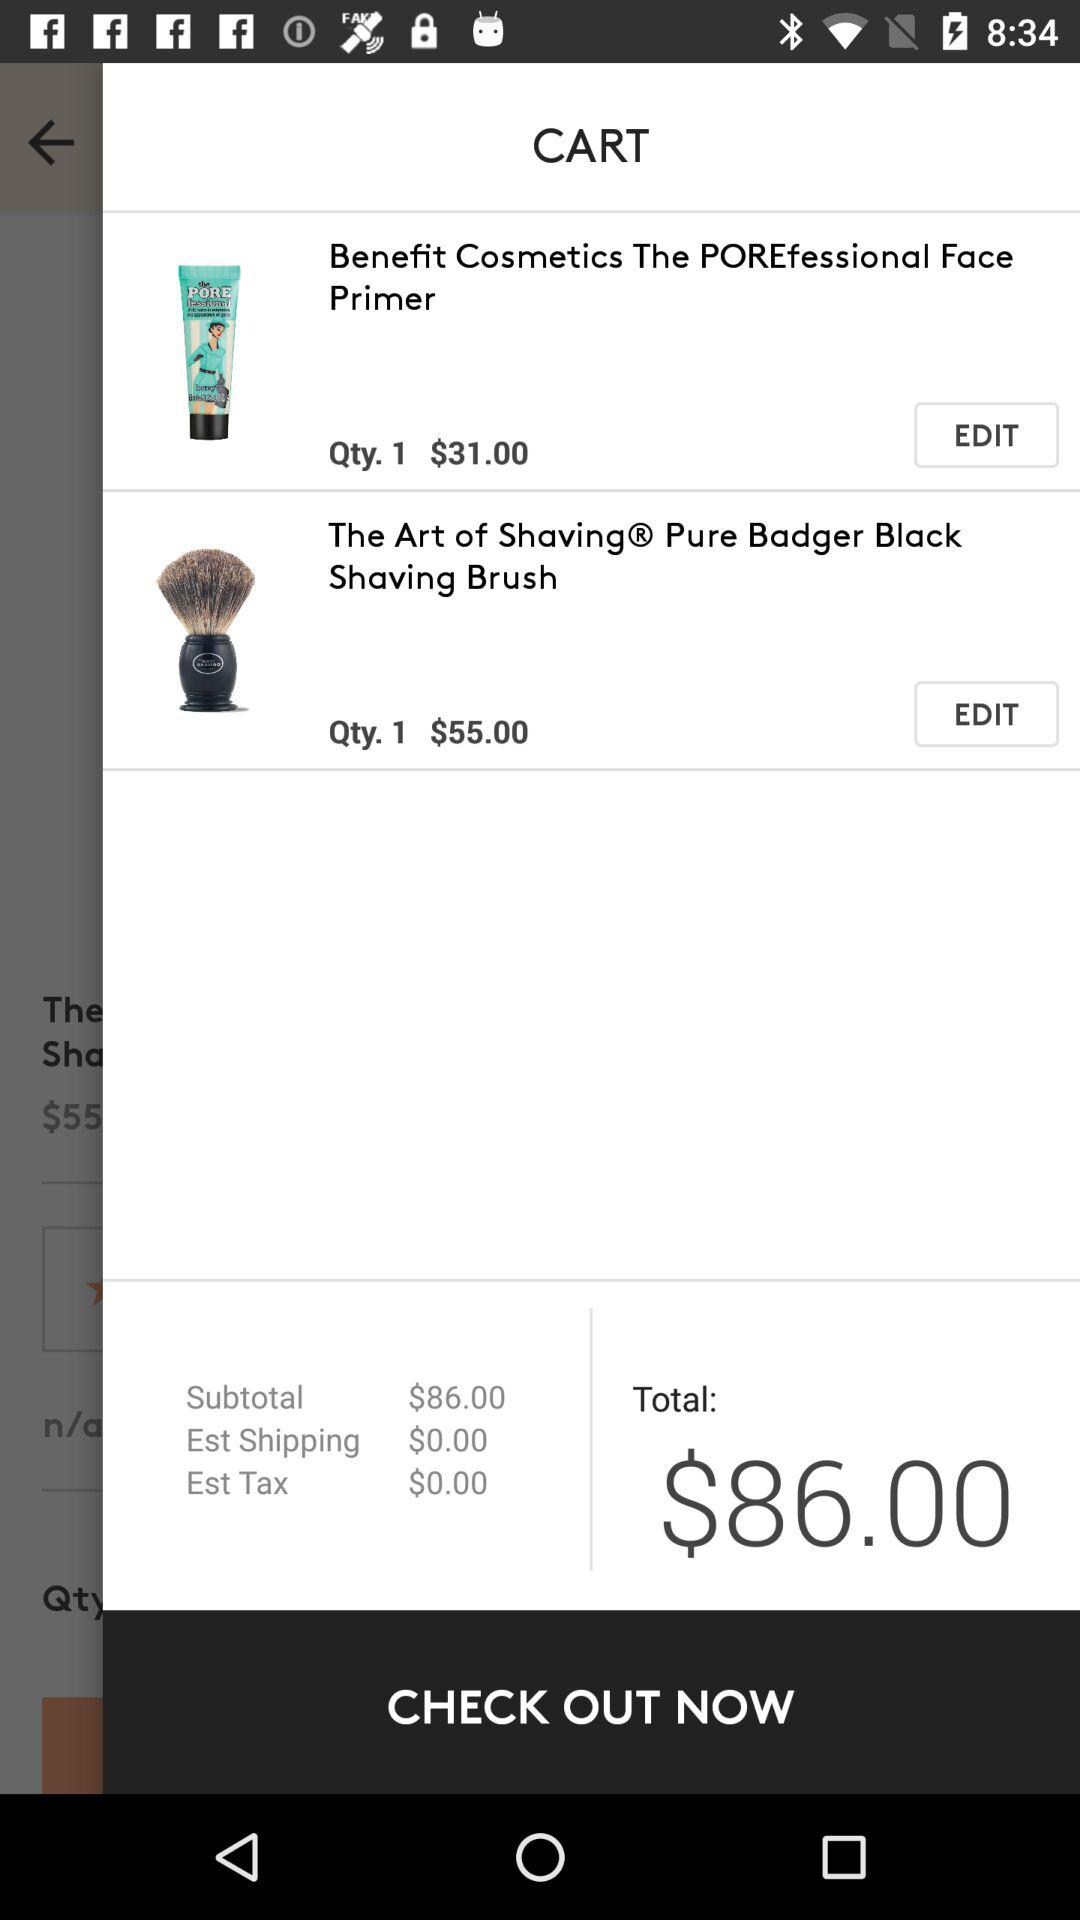What is the price of the "Pure Badger Black Shaving Brush"? The price is $55. 